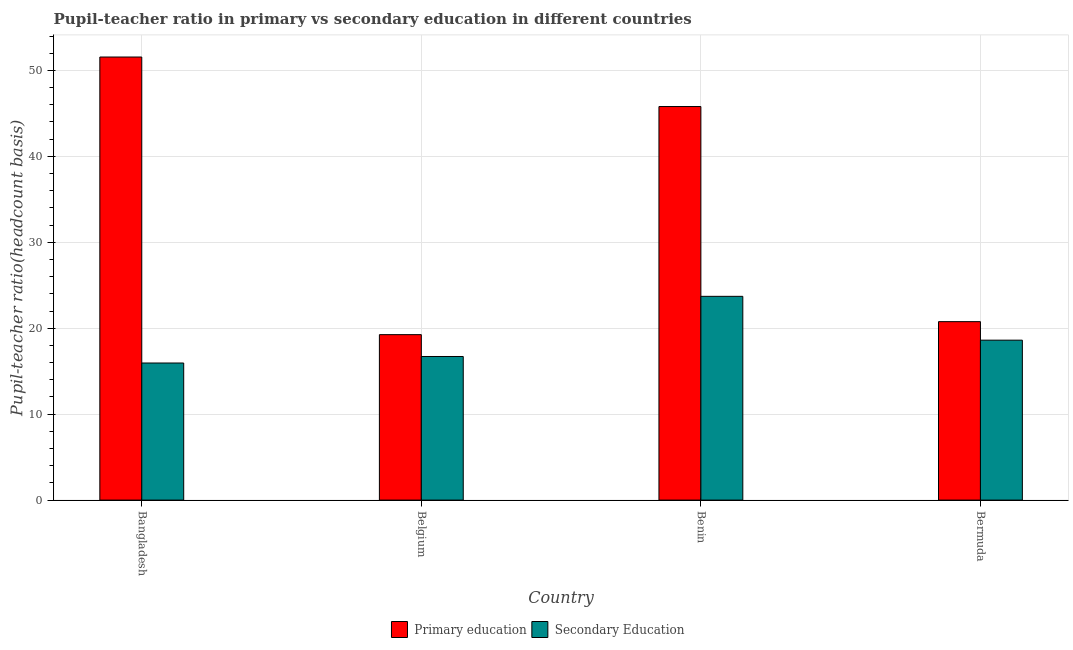How many different coloured bars are there?
Your answer should be compact. 2. How many groups of bars are there?
Provide a short and direct response. 4. Are the number of bars on each tick of the X-axis equal?
Give a very brief answer. Yes. How many bars are there on the 3rd tick from the left?
Your response must be concise. 2. How many bars are there on the 1st tick from the right?
Your answer should be very brief. 2. What is the label of the 4th group of bars from the left?
Your response must be concise. Bermuda. What is the pupil-teacher ratio in primary education in Benin?
Your answer should be compact. 45.8. Across all countries, what is the maximum pupil-teacher ratio in primary education?
Make the answer very short. 51.56. Across all countries, what is the minimum pupil-teacher ratio in primary education?
Ensure brevity in your answer.  19.25. In which country was the pupil teacher ratio on secondary education maximum?
Provide a short and direct response. Benin. What is the total pupil teacher ratio on secondary education in the graph?
Make the answer very short. 74.99. What is the difference between the pupil teacher ratio on secondary education in Belgium and that in Bermuda?
Make the answer very short. -1.9. What is the difference between the pupil teacher ratio on secondary education in Bangladesh and the pupil-teacher ratio in primary education in Belgium?
Make the answer very short. -3.3. What is the average pupil-teacher ratio in primary education per country?
Offer a terse response. 34.34. What is the difference between the pupil-teacher ratio in primary education and pupil teacher ratio on secondary education in Belgium?
Keep it short and to the point. 2.54. What is the ratio of the pupil teacher ratio on secondary education in Bangladesh to that in Benin?
Offer a terse response. 0.67. What is the difference between the highest and the second highest pupil-teacher ratio in primary education?
Your response must be concise. 5.76. What is the difference between the highest and the lowest pupil-teacher ratio in primary education?
Your response must be concise. 32.3. What does the 2nd bar from the left in Bermuda represents?
Offer a very short reply. Secondary Education. What does the 2nd bar from the right in Bermuda represents?
Give a very brief answer. Primary education. Are the values on the major ticks of Y-axis written in scientific E-notation?
Your answer should be very brief. No. Does the graph contain grids?
Provide a succinct answer. Yes. Where does the legend appear in the graph?
Provide a succinct answer. Bottom center. How are the legend labels stacked?
Give a very brief answer. Horizontal. What is the title of the graph?
Keep it short and to the point. Pupil-teacher ratio in primary vs secondary education in different countries. Does "Frequency of shipment arrival" appear as one of the legend labels in the graph?
Provide a short and direct response. No. What is the label or title of the Y-axis?
Provide a short and direct response. Pupil-teacher ratio(headcount basis). What is the Pupil-teacher ratio(headcount basis) of Primary education in Bangladesh?
Your response must be concise. 51.56. What is the Pupil-teacher ratio(headcount basis) of Secondary Education in Bangladesh?
Your answer should be compact. 15.95. What is the Pupil-teacher ratio(headcount basis) in Primary education in Belgium?
Offer a terse response. 19.25. What is the Pupil-teacher ratio(headcount basis) in Secondary Education in Belgium?
Provide a succinct answer. 16.71. What is the Pupil-teacher ratio(headcount basis) of Primary education in Benin?
Give a very brief answer. 45.8. What is the Pupil-teacher ratio(headcount basis) in Secondary Education in Benin?
Provide a succinct answer. 23.71. What is the Pupil-teacher ratio(headcount basis) of Primary education in Bermuda?
Provide a short and direct response. 20.77. What is the Pupil-teacher ratio(headcount basis) of Secondary Education in Bermuda?
Your answer should be compact. 18.61. Across all countries, what is the maximum Pupil-teacher ratio(headcount basis) in Primary education?
Make the answer very short. 51.56. Across all countries, what is the maximum Pupil-teacher ratio(headcount basis) in Secondary Education?
Your response must be concise. 23.71. Across all countries, what is the minimum Pupil-teacher ratio(headcount basis) in Primary education?
Offer a very short reply. 19.25. Across all countries, what is the minimum Pupil-teacher ratio(headcount basis) in Secondary Education?
Provide a short and direct response. 15.95. What is the total Pupil-teacher ratio(headcount basis) of Primary education in the graph?
Provide a succinct answer. 137.37. What is the total Pupil-teacher ratio(headcount basis) of Secondary Education in the graph?
Ensure brevity in your answer.  74.99. What is the difference between the Pupil-teacher ratio(headcount basis) of Primary education in Bangladesh and that in Belgium?
Keep it short and to the point. 32.3. What is the difference between the Pupil-teacher ratio(headcount basis) of Secondary Education in Bangladesh and that in Belgium?
Provide a succinct answer. -0.76. What is the difference between the Pupil-teacher ratio(headcount basis) of Primary education in Bangladesh and that in Benin?
Provide a short and direct response. 5.76. What is the difference between the Pupil-teacher ratio(headcount basis) in Secondary Education in Bangladesh and that in Benin?
Provide a short and direct response. -7.76. What is the difference between the Pupil-teacher ratio(headcount basis) in Primary education in Bangladesh and that in Bermuda?
Ensure brevity in your answer.  30.79. What is the difference between the Pupil-teacher ratio(headcount basis) in Secondary Education in Bangladesh and that in Bermuda?
Ensure brevity in your answer.  -2.66. What is the difference between the Pupil-teacher ratio(headcount basis) in Primary education in Belgium and that in Benin?
Provide a succinct answer. -26.54. What is the difference between the Pupil-teacher ratio(headcount basis) of Secondary Education in Belgium and that in Benin?
Offer a terse response. -7. What is the difference between the Pupil-teacher ratio(headcount basis) in Primary education in Belgium and that in Bermuda?
Give a very brief answer. -1.51. What is the difference between the Pupil-teacher ratio(headcount basis) of Secondary Education in Belgium and that in Bermuda?
Offer a very short reply. -1.9. What is the difference between the Pupil-teacher ratio(headcount basis) in Primary education in Benin and that in Bermuda?
Your response must be concise. 25.03. What is the difference between the Pupil-teacher ratio(headcount basis) in Secondary Education in Benin and that in Bermuda?
Make the answer very short. 5.1. What is the difference between the Pupil-teacher ratio(headcount basis) of Primary education in Bangladesh and the Pupil-teacher ratio(headcount basis) of Secondary Education in Belgium?
Make the answer very short. 34.85. What is the difference between the Pupil-teacher ratio(headcount basis) in Primary education in Bangladesh and the Pupil-teacher ratio(headcount basis) in Secondary Education in Benin?
Make the answer very short. 27.85. What is the difference between the Pupil-teacher ratio(headcount basis) of Primary education in Bangladesh and the Pupil-teacher ratio(headcount basis) of Secondary Education in Bermuda?
Provide a succinct answer. 32.95. What is the difference between the Pupil-teacher ratio(headcount basis) in Primary education in Belgium and the Pupil-teacher ratio(headcount basis) in Secondary Education in Benin?
Make the answer very short. -4.46. What is the difference between the Pupil-teacher ratio(headcount basis) of Primary education in Belgium and the Pupil-teacher ratio(headcount basis) of Secondary Education in Bermuda?
Make the answer very short. 0.64. What is the difference between the Pupil-teacher ratio(headcount basis) of Primary education in Benin and the Pupil-teacher ratio(headcount basis) of Secondary Education in Bermuda?
Your answer should be compact. 27.19. What is the average Pupil-teacher ratio(headcount basis) in Primary education per country?
Keep it short and to the point. 34.34. What is the average Pupil-teacher ratio(headcount basis) in Secondary Education per country?
Offer a terse response. 18.75. What is the difference between the Pupil-teacher ratio(headcount basis) of Primary education and Pupil-teacher ratio(headcount basis) of Secondary Education in Bangladesh?
Your response must be concise. 35.61. What is the difference between the Pupil-teacher ratio(headcount basis) in Primary education and Pupil-teacher ratio(headcount basis) in Secondary Education in Belgium?
Your answer should be compact. 2.54. What is the difference between the Pupil-teacher ratio(headcount basis) of Primary education and Pupil-teacher ratio(headcount basis) of Secondary Education in Benin?
Keep it short and to the point. 22.09. What is the difference between the Pupil-teacher ratio(headcount basis) in Primary education and Pupil-teacher ratio(headcount basis) in Secondary Education in Bermuda?
Keep it short and to the point. 2.15. What is the ratio of the Pupil-teacher ratio(headcount basis) of Primary education in Bangladesh to that in Belgium?
Give a very brief answer. 2.68. What is the ratio of the Pupil-teacher ratio(headcount basis) in Secondary Education in Bangladesh to that in Belgium?
Make the answer very short. 0.95. What is the ratio of the Pupil-teacher ratio(headcount basis) in Primary education in Bangladesh to that in Benin?
Your response must be concise. 1.13. What is the ratio of the Pupil-teacher ratio(headcount basis) in Secondary Education in Bangladesh to that in Benin?
Your answer should be very brief. 0.67. What is the ratio of the Pupil-teacher ratio(headcount basis) of Primary education in Bangladesh to that in Bermuda?
Offer a terse response. 2.48. What is the ratio of the Pupil-teacher ratio(headcount basis) in Secondary Education in Bangladesh to that in Bermuda?
Offer a terse response. 0.86. What is the ratio of the Pupil-teacher ratio(headcount basis) in Primary education in Belgium to that in Benin?
Give a very brief answer. 0.42. What is the ratio of the Pupil-teacher ratio(headcount basis) in Secondary Education in Belgium to that in Benin?
Give a very brief answer. 0.7. What is the ratio of the Pupil-teacher ratio(headcount basis) of Primary education in Belgium to that in Bermuda?
Your answer should be very brief. 0.93. What is the ratio of the Pupil-teacher ratio(headcount basis) in Secondary Education in Belgium to that in Bermuda?
Provide a short and direct response. 0.9. What is the ratio of the Pupil-teacher ratio(headcount basis) of Primary education in Benin to that in Bermuda?
Provide a succinct answer. 2.21. What is the ratio of the Pupil-teacher ratio(headcount basis) in Secondary Education in Benin to that in Bermuda?
Offer a terse response. 1.27. What is the difference between the highest and the second highest Pupil-teacher ratio(headcount basis) of Primary education?
Offer a terse response. 5.76. What is the difference between the highest and the second highest Pupil-teacher ratio(headcount basis) in Secondary Education?
Your answer should be very brief. 5.1. What is the difference between the highest and the lowest Pupil-teacher ratio(headcount basis) in Primary education?
Your response must be concise. 32.3. What is the difference between the highest and the lowest Pupil-teacher ratio(headcount basis) in Secondary Education?
Offer a terse response. 7.76. 